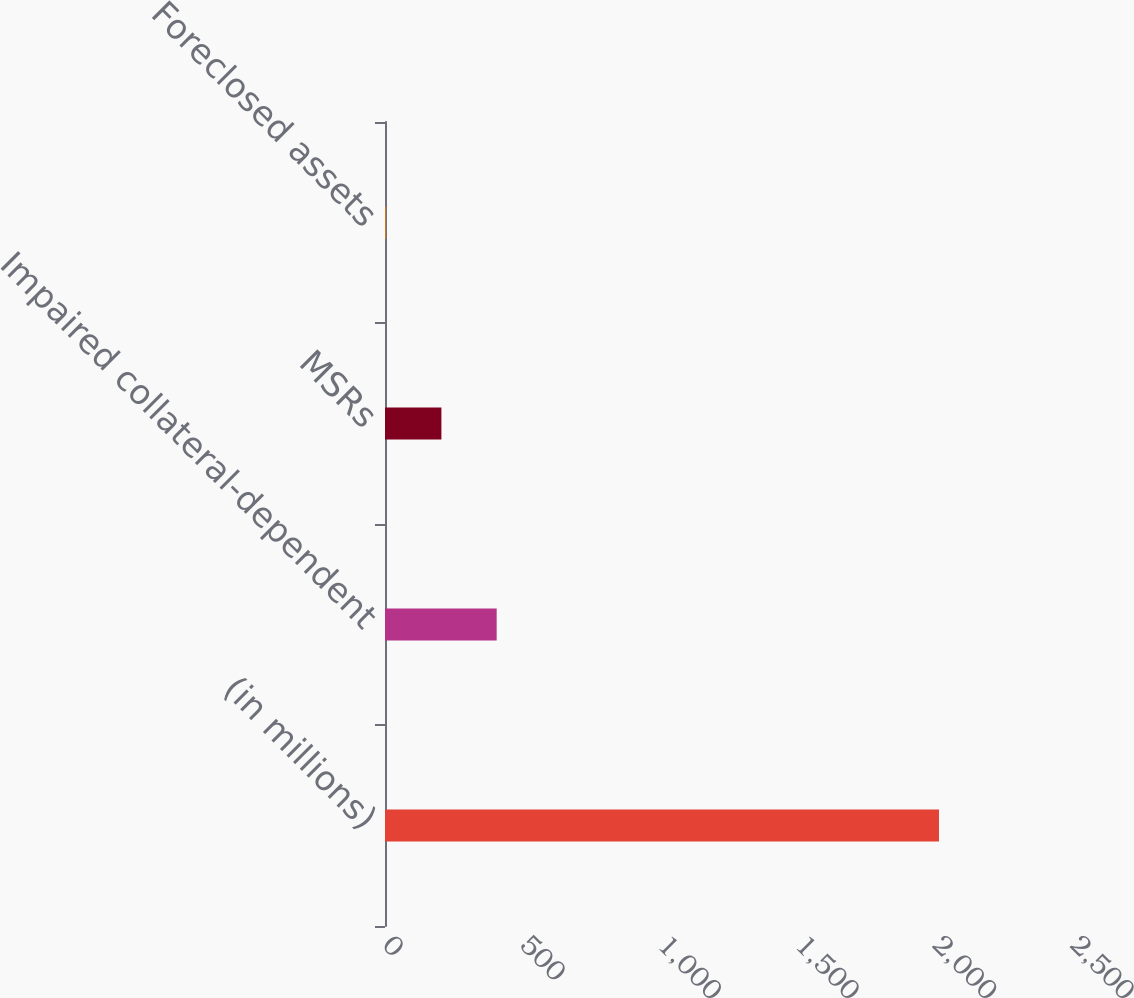Convert chart. <chart><loc_0><loc_0><loc_500><loc_500><bar_chart><fcel>(in millions)<fcel>Impaired collateral-dependent<fcel>MSRs<fcel>Foreclosed assets<nl><fcel>2013<fcel>405.8<fcel>204.9<fcel>4<nl></chart> 